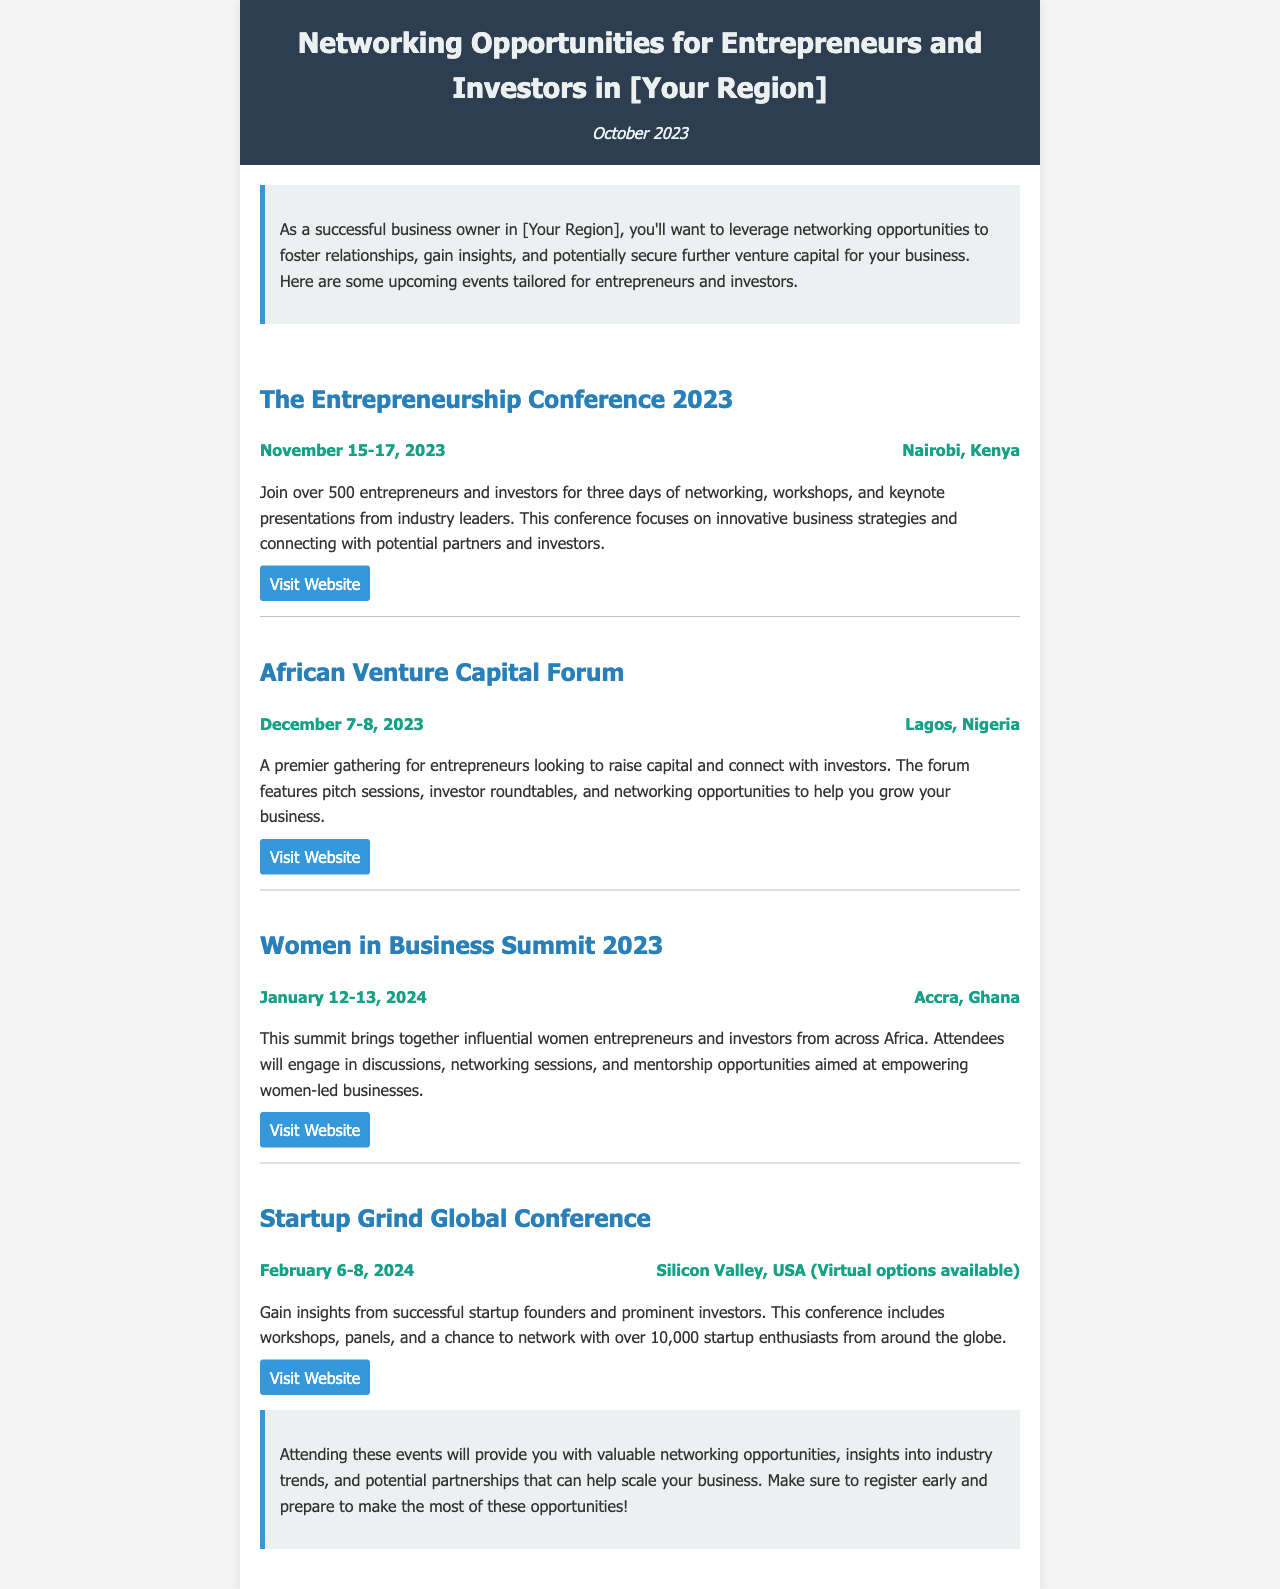What is the title of the first event? The title of the first event listed in the document is "The Entrepreneurship Conference 2023."
Answer: The Entrepreneurship Conference 2023 When will the African Venture Capital Forum take place? The date of the African Venture Capital Forum is clearly stated in the document as December 7-8, 2023.
Answer: December 7-8, 2023 Where is the Women in Business Summit 2023 being held? The location for the Women in Business Summit 2023 is specified as Accra, Ghana.
Answer: Accra, Ghana How many days will the Startup Grind Global Conference last? The document mentions that the Startup Grind Global Conference is from February 6-8, 2024, making it last for three days.
Answer: Three days What is the focus of the Entrepreneurship Conference 2023? The document states that the focus is on innovative business strategies and connecting with potential partners and investors.
Answer: Innovative business strategies and connecting with potential partners and investors Which event includes virtual options? The Startup Grind Global Conference includes virtual options as indicated in its description.
Answer: Startup Grind Global Conference What type of attendees is the Women in Business Summit targeting? The Women in Business Summit is specifically targeting influential women entrepreneurs and investors.
Answer: Influential women entrepreneurs and investors What can attendees expect at the African Venture Capital Forum? Attendees can expect pitch sessions, investor roundtables, and networking opportunities at the African Venture Capital Forum.
Answer: Pitch sessions, investor roundtables, and networking opportunities 